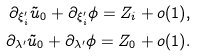<formula> <loc_0><loc_0><loc_500><loc_500>\partial _ { \xi ^ { \prime } _ { i } } \tilde { u } _ { 0 } + \partial _ { \xi ^ { \prime } _ { i } } \phi = Z _ { i } + o ( 1 ) , \\ \partial _ { \lambda ^ { \prime } } \tilde { u } _ { 0 } + \partial _ { \lambda ^ { \prime } } \phi = Z _ { 0 } + o ( 1 ) .</formula> 